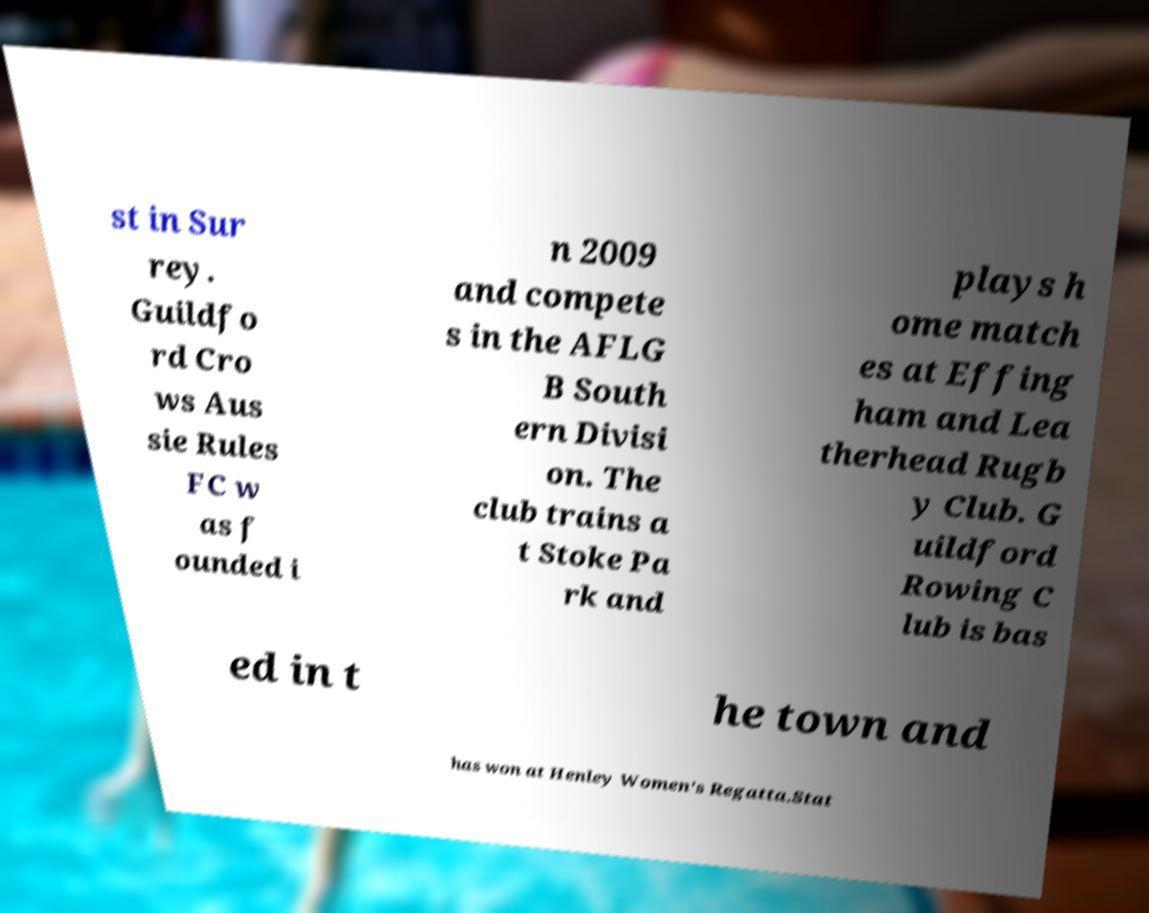Could you extract and type out the text from this image? st in Sur rey. Guildfo rd Cro ws Aus sie Rules FC w as f ounded i n 2009 and compete s in the AFLG B South ern Divisi on. The club trains a t Stoke Pa rk and plays h ome match es at Effing ham and Lea therhead Rugb y Club. G uildford Rowing C lub is bas ed in t he town and has won at Henley Women's Regatta.Stat 